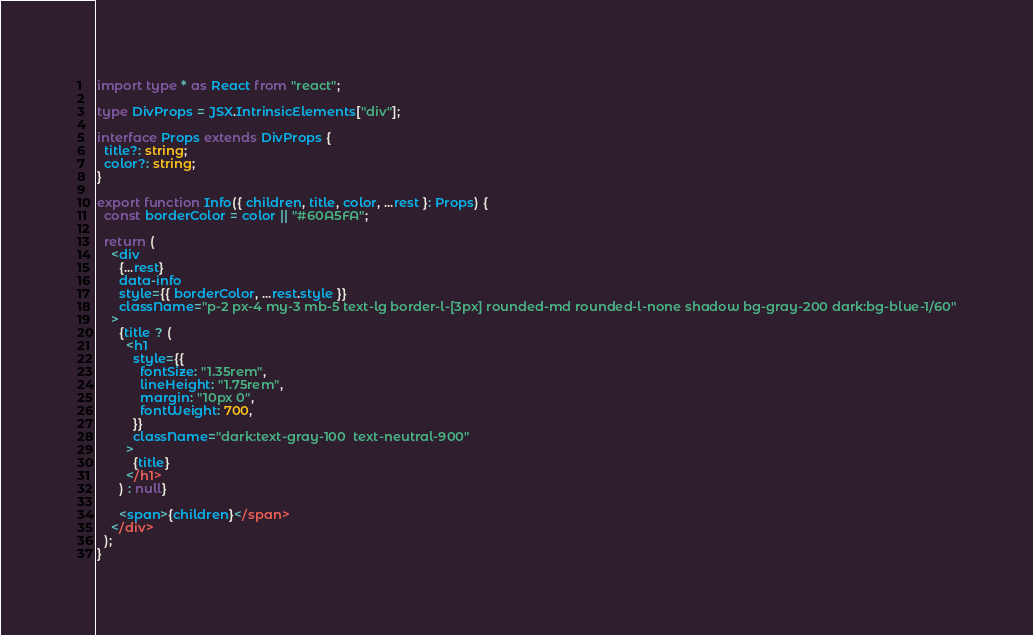<code> <loc_0><loc_0><loc_500><loc_500><_TypeScript_>import type * as React from "react";

type DivProps = JSX.IntrinsicElements["div"];

interface Props extends DivProps {
  title?: string;
  color?: string;
}

export function Info({ children, title, color, ...rest }: Props) {
  const borderColor = color || "#60A5FA";

  return (
    <div
      {...rest}
      data-info
      style={{ borderColor, ...rest.style }}
      className="p-2 px-4 my-3 mb-5 text-lg border-l-[3px] rounded-md rounded-l-none shadow bg-gray-200 dark:bg-blue-1/60"
    >
      {title ? (
        <h1
          style={{
            fontSize: "1.35rem",
            lineHeight: "1.75rem",
            margin: "10px 0",
            fontWeight: 700,
          }}
          className="dark:text-gray-100  text-neutral-900"
        >
          {title}
        </h1>
      ) : null}

      <span>{children}</span>
    </div>
  );
}
</code> 